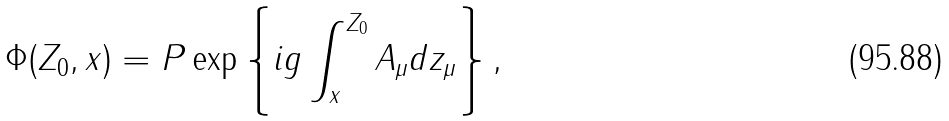<formula> <loc_0><loc_0><loc_500><loc_500>\Phi ( Z _ { 0 } , x ) = P \exp \left \{ i g \int _ { x } ^ { Z _ { 0 } } A _ { \mu } d z _ { \mu } \right \} ,</formula> 